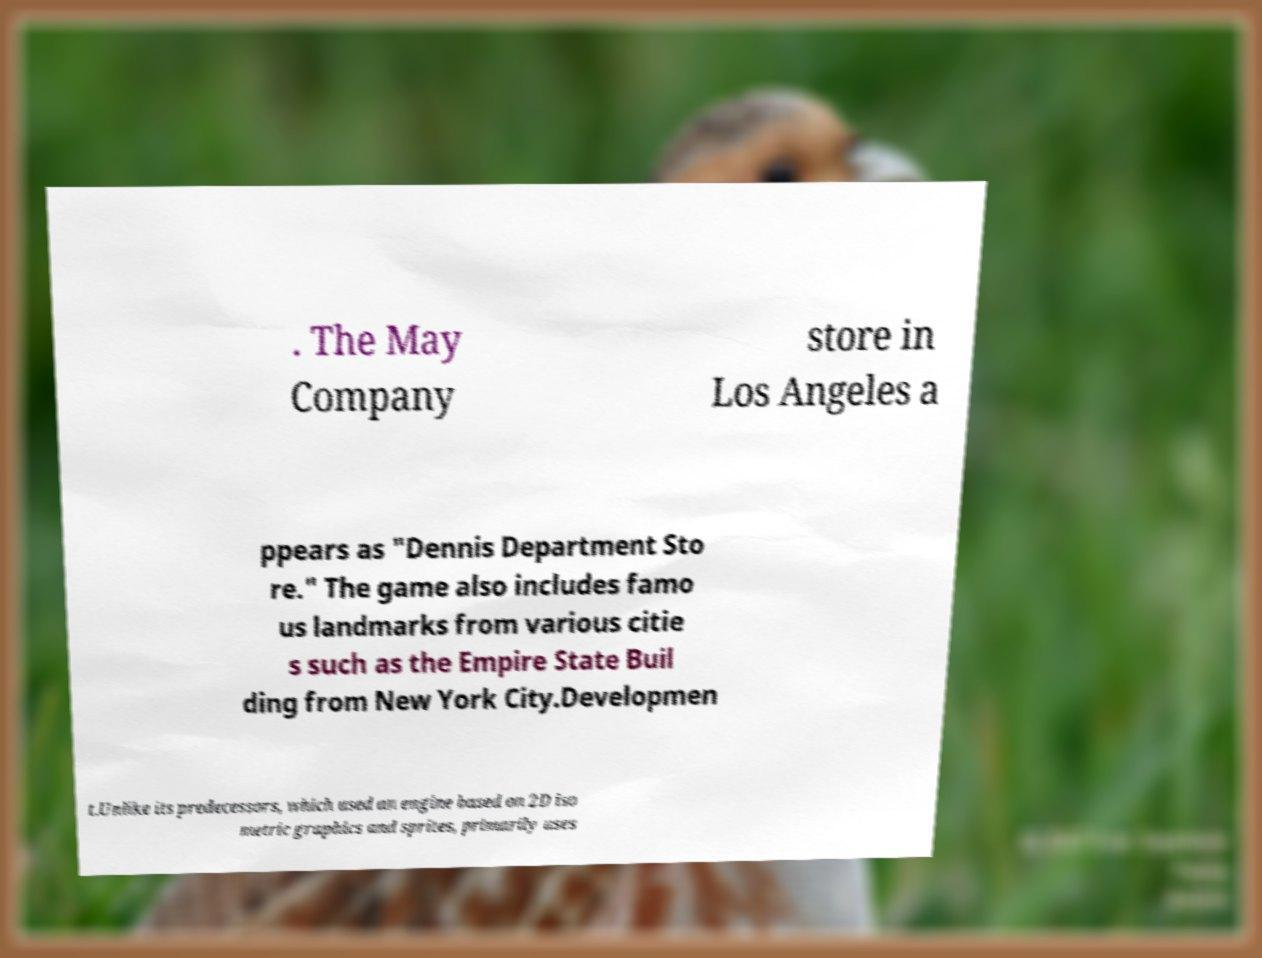What messages or text are displayed in this image? I need them in a readable, typed format. . The May Company store in Los Angeles a ppears as "Dennis Department Sto re." The game also includes famo us landmarks from various citie s such as the Empire State Buil ding from New York City.Developmen t.Unlike its predecessors, which used an engine based on 2D iso metric graphics and sprites, primarily uses 